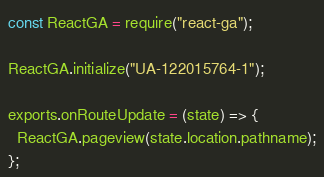<code> <loc_0><loc_0><loc_500><loc_500><_JavaScript_>const ReactGA = require("react-ga");

ReactGA.initialize("UA-122015764-1");

exports.onRouteUpdate = (state) => {
  ReactGA.pageview(state.location.pathname);
};
</code> 